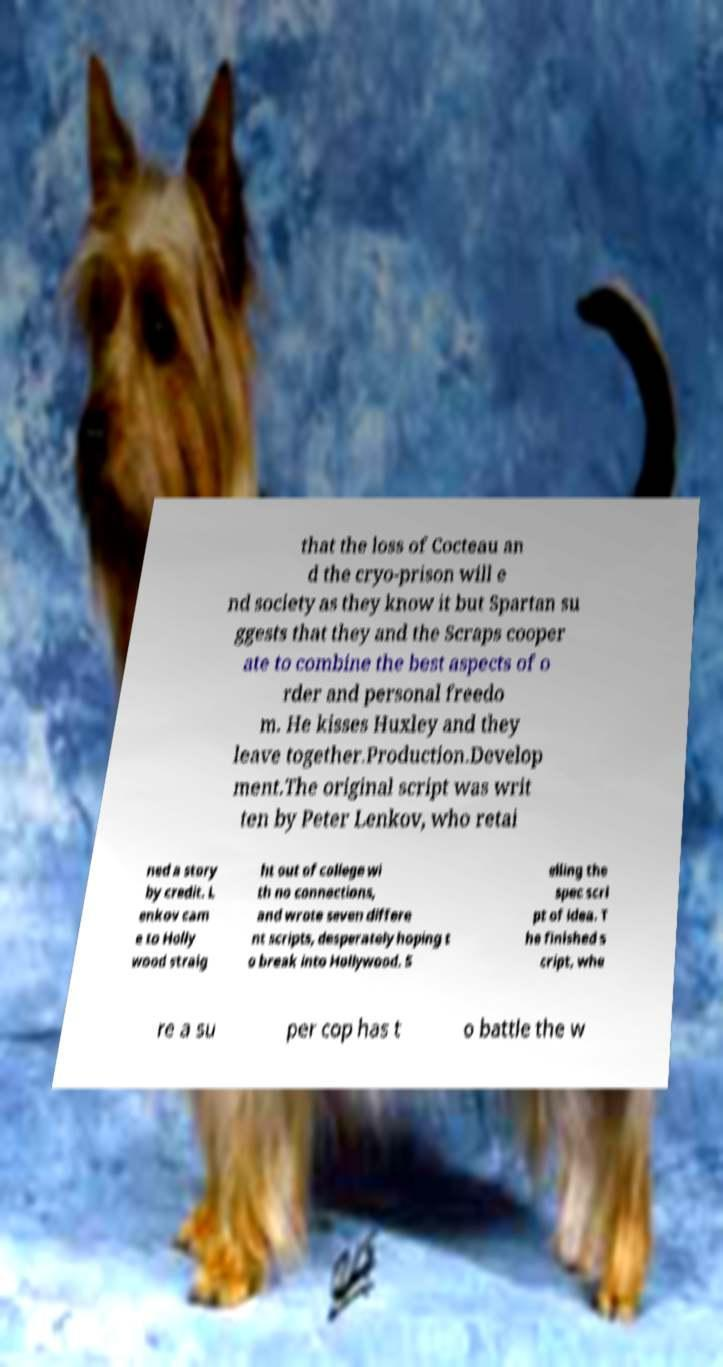Can you read and provide the text displayed in the image?This photo seems to have some interesting text. Can you extract and type it out for me? that the loss of Cocteau an d the cryo-prison will e nd society as they know it but Spartan su ggests that they and the Scraps cooper ate to combine the best aspects of o rder and personal freedo m. He kisses Huxley and they leave together.Production.Develop ment.The original script was writ ten by Peter Lenkov, who retai ned a story by credit. L enkov cam e to Holly wood straig ht out of college wi th no connections, and wrote seven differe nt scripts, desperately hoping t o break into Hollywood. S elling the spec scri pt of idea. T he finished s cript, whe re a su per cop has t o battle the w 